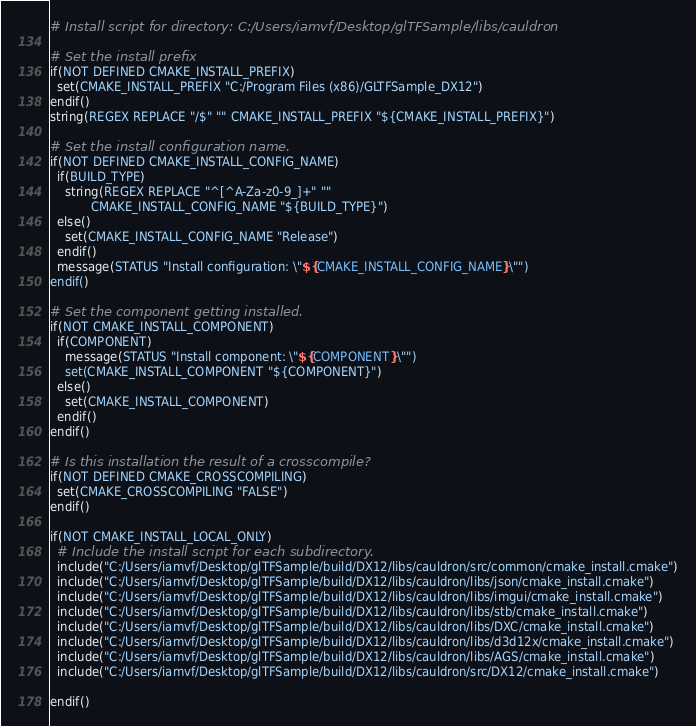Convert code to text. <code><loc_0><loc_0><loc_500><loc_500><_CMake_># Install script for directory: C:/Users/iamvf/Desktop/glTFSample/libs/cauldron

# Set the install prefix
if(NOT DEFINED CMAKE_INSTALL_PREFIX)
  set(CMAKE_INSTALL_PREFIX "C:/Program Files (x86)/GLTFSample_DX12")
endif()
string(REGEX REPLACE "/$" "" CMAKE_INSTALL_PREFIX "${CMAKE_INSTALL_PREFIX}")

# Set the install configuration name.
if(NOT DEFINED CMAKE_INSTALL_CONFIG_NAME)
  if(BUILD_TYPE)
    string(REGEX REPLACE "^[^A-Za-z0-9_]+" ""
           CMAKE_INSTALL_CONFIG_NAME "${BUILD_TYPE}")
  else()
    set(CMAKE_INSTALL_CONFIG_NAME "Release")
  endif()
  message(STATUS "Install configuration: \"${CMAKE_INSTALL_CONFIG_NAME}\"")
endif()

# Set the component getting installed.
if(NOT CMAKE_INSTALL_COMPONENT)
  if(COMPONENT)
    message(STATUS "Install component: \"${COMPONENT}\"")
    set(CMAKE_INSTALL_COMPONENT "${COMPONENT}")
  else()
    set(CMAKE_INSTALL_COMPONENT)
  endif()
endif()

# Is this installation the result of a crosscompile?
if(NOT DEFINED CMAKE_CROSSCOMPILING)
  set(CMAKE_CROSSCOMPILING "FALSE")
endif()

if(NOT CMAKE_INSTALL_LOCAL_ONLY)
  # Include the install script for each subdirectory.
  include("C:/Users/iamvf/Desktop/glTFSample/build/DX12/libs/cauldron/src/common/cmake_install.cmake")
  include("C:/Users/iamvf/Desktop/glTFSample/build/DX12/libs/cauldron/libs/json/cmake_install.cmake")
  include("C:/Users/iamvf/Desktop/glTFSample/build/DX12/libs/cauldron/libs/imgui/cmake_install.cmake")
  include("C:/Users/iamvf/Desktop/glTFSample/build/DX12/libs/cauldron/libs/stb/cmake_install.cmake")
  include("C:/Users/iamvf/Desktop/glTFSample/build/DX12/libs/cauldron/libs/DXC/cmake_install.cmake")
  include("C:/Users/iamvf/Desktop/glTFSample/build/DX12/libs/cauldron/libs/d3d12x/cmake_install.cmake")
  include("C:/Users/iamvf/Desktop/glTFSample/build/DX12/libs/cauldron/libs/AGS/cmake_install.cmake")
  include("C:/Users/iamvf/Desktop/glTFSample/build/DX12/libs/cauldron/src/DX12/cmake_install.cmake")

endif()

</code> 